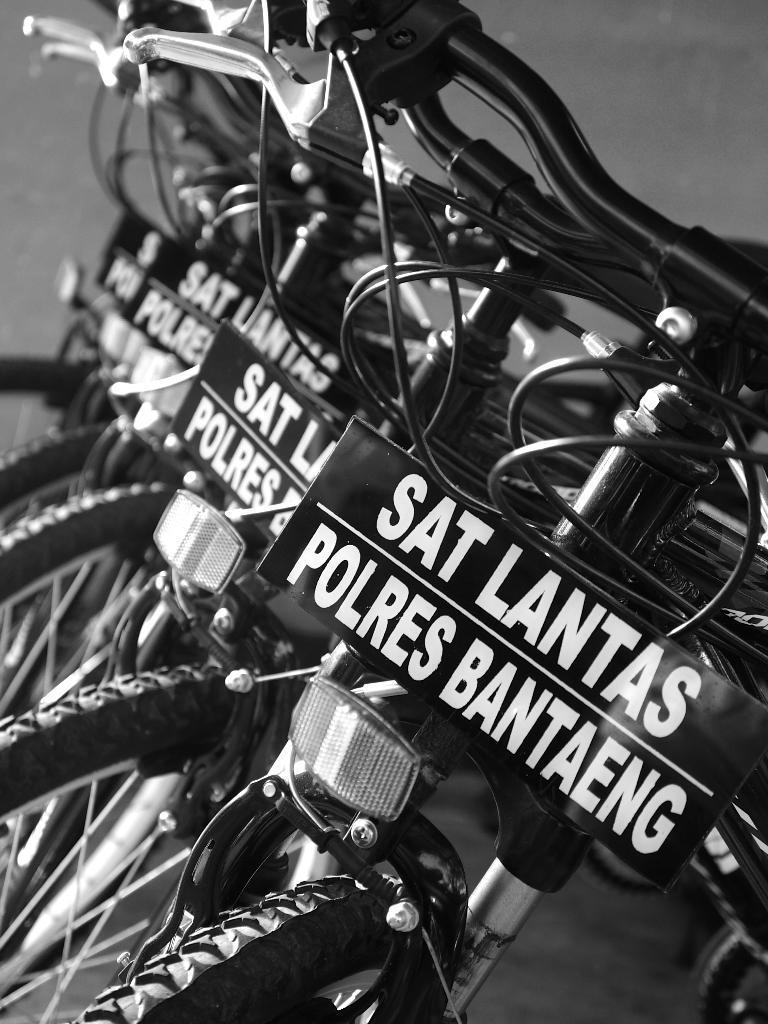In one or two sentences, can you explain what this image depicts? In this image we can see a few bicycles parked and their board attached to the cycle with text on it. 